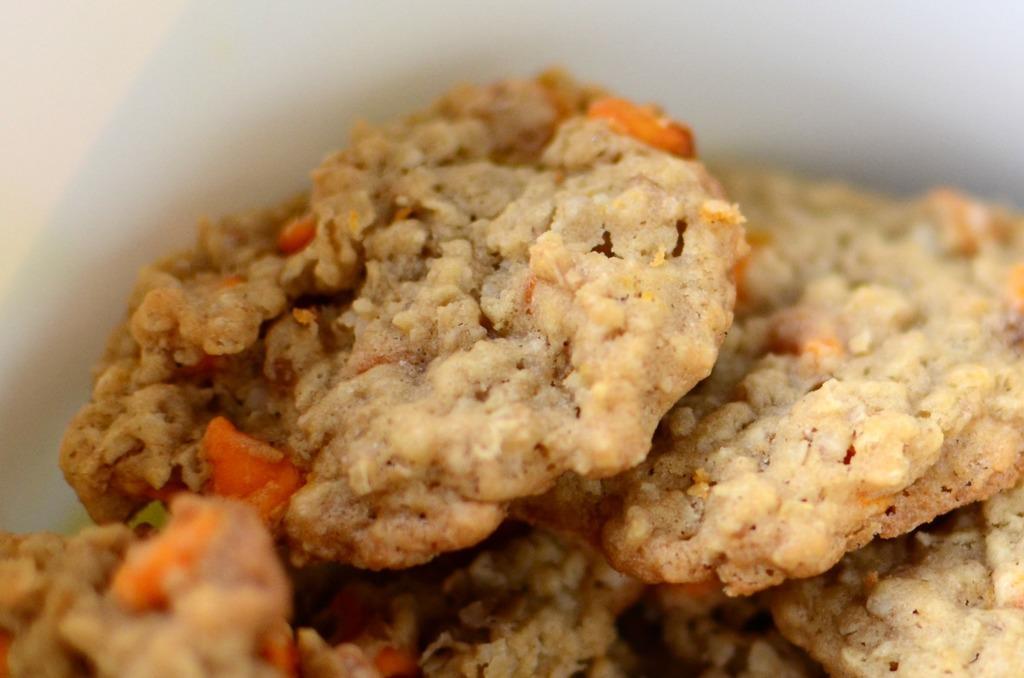Describe this image in one or two sentences. In this image we can see a food item. In the background of the image there is a white object. 